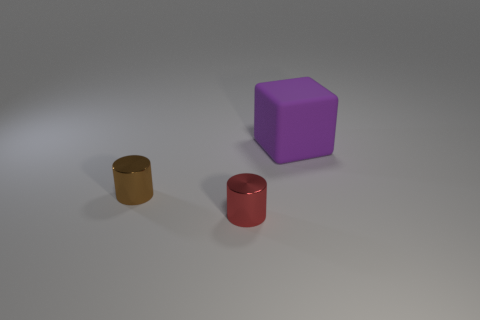Add 2 small brown cylinders. How many objects exist? 5 Subtract all cylinders. How many objects are left? 1 Add 2 large purple rubber blocks. How many large purple rubber blocks exist? 3 Subtract 0 cyan blocks. How many objects are left? 3 Subtract all cubes. Subtract all shiny things. How many objects are left? 0 Add 3 red shiny things. How many red shiny things are left? 4 